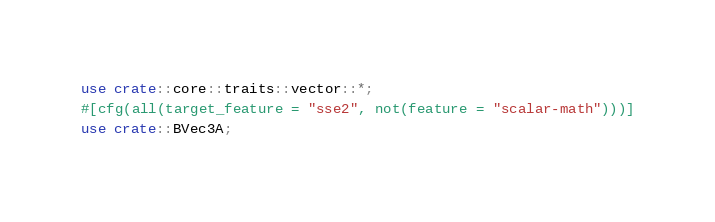Convert code to text. <code><loc_0><loc_0><loc_500><loc_500><_Rust_>use crate::core::traits::vector::*;
#[cfg(all(target_feature = "sse2", not(feature = "scalar-math")))]
use crate::BVec3A;</code> 